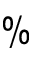<formula> <loc_0><loc_0><loc_500><loc_500>\%</formula> 